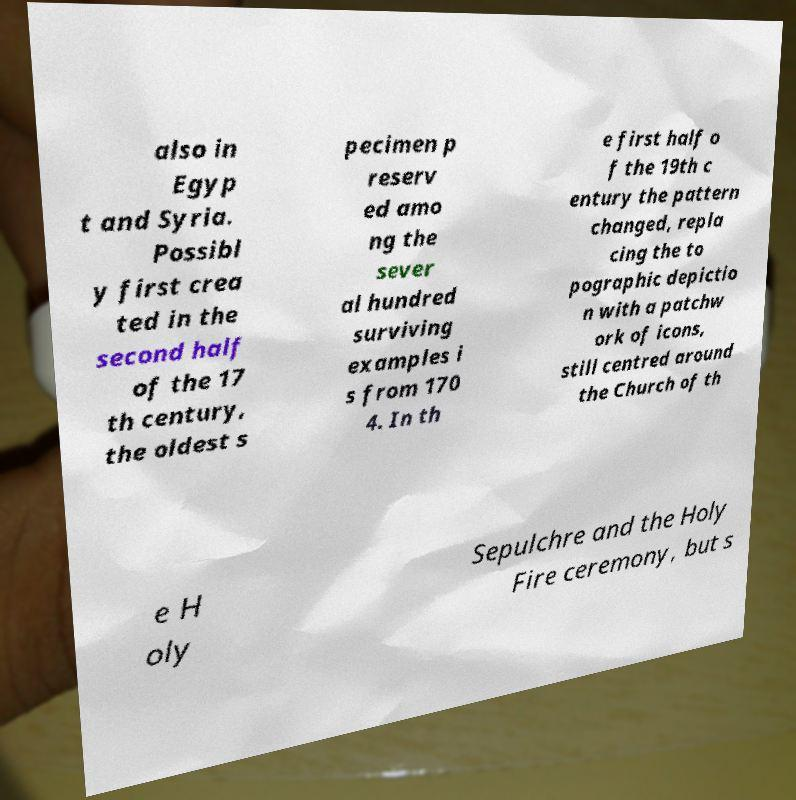Could you assist in decoding the text presented in this image and type it out clearly? also in Egyp t and Syria. Possibl y first crea ted in the second half of the 17 th century, the oldest s pecimen p reserv ed amo ng the sever al hundred surviving examples i s from 170 4. In th e first half o f the 19th c entury the pattern changed, repla cing the to pographic depictio n with a patchw ork of icons, still centred around the Church of th e H oly Sepulchre and the Holy Fire ceremony, but s 